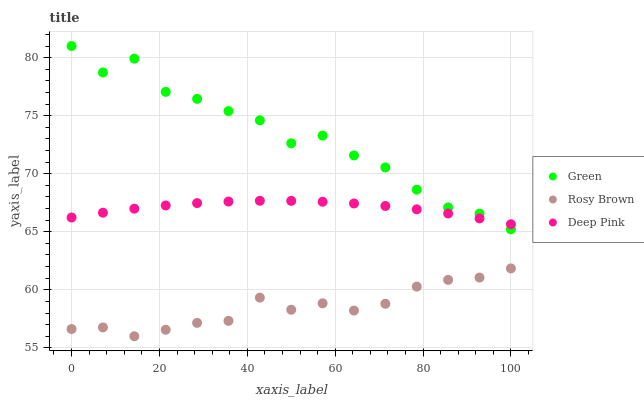Does Rosy Brown have the minimum area under the curve?
Answer yes or no. Yes. Does Green have the maximum area under the curve?
Answer yes or no. Yes. Does Deep Pink have the minimum area under the curve?
Answer yes or no. No. Does Deep Pink have the maximum area under the curve?
Answer yes or no. No. Is Deep Pink the smoothest?
Answer yes or no. Yes. Is Green the roughest?
Answer yes or no. Yes. Is Green the smoothest?
Answer yes or no. No. Is Deep Pink the roughest?
Answer yes or no. No. Does Rosy Brown have the lowest value?
Answer yes or no. Yes. Does Green have the lowest value?
Answer yes or no. No. Does Green have the highest value?
Answer yes or no. Yes. Does Deep Pink have the highest value?
Answer yes or no. No. Is Rosy Brown less than Green?
Answer yes or no. Yes. Is Green greater than Rosy Brown?
Answer yes or no. Yes. Does Green intersect Deep Pink?
Answer yes or no. Yes. Is Green less than Deep Pink?
Answer yes or no. No. Is Green greater than Deep Pink?
Answer yes or no. No. Does Rosy Brown intersect Green?
Answer yes or no. No. 